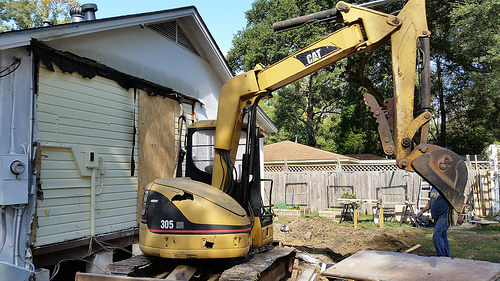<image>
Is the house behind the equipment? Yes. From this viewpoint, the house is positioned behind the equipment, with the equipment partially or fully occluding the house. 